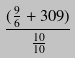Convert formula to latex. <formula><loc_0><loc_0><loc_500><loc_500>\frac { ( \frac { 9 } { 6 } + 3 0 9 ) } { \frac { 1 0 } { 1 0 } }</formula> 